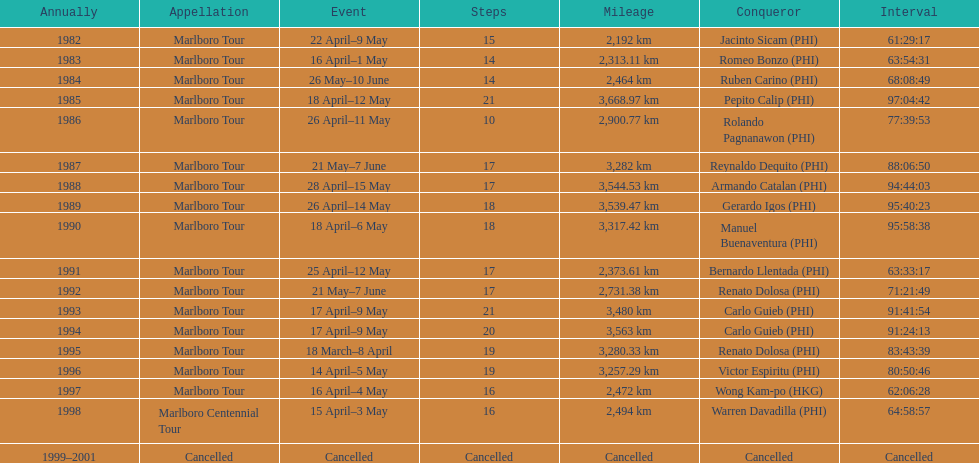How many marlboro tours did carlo guieb win? 2. 